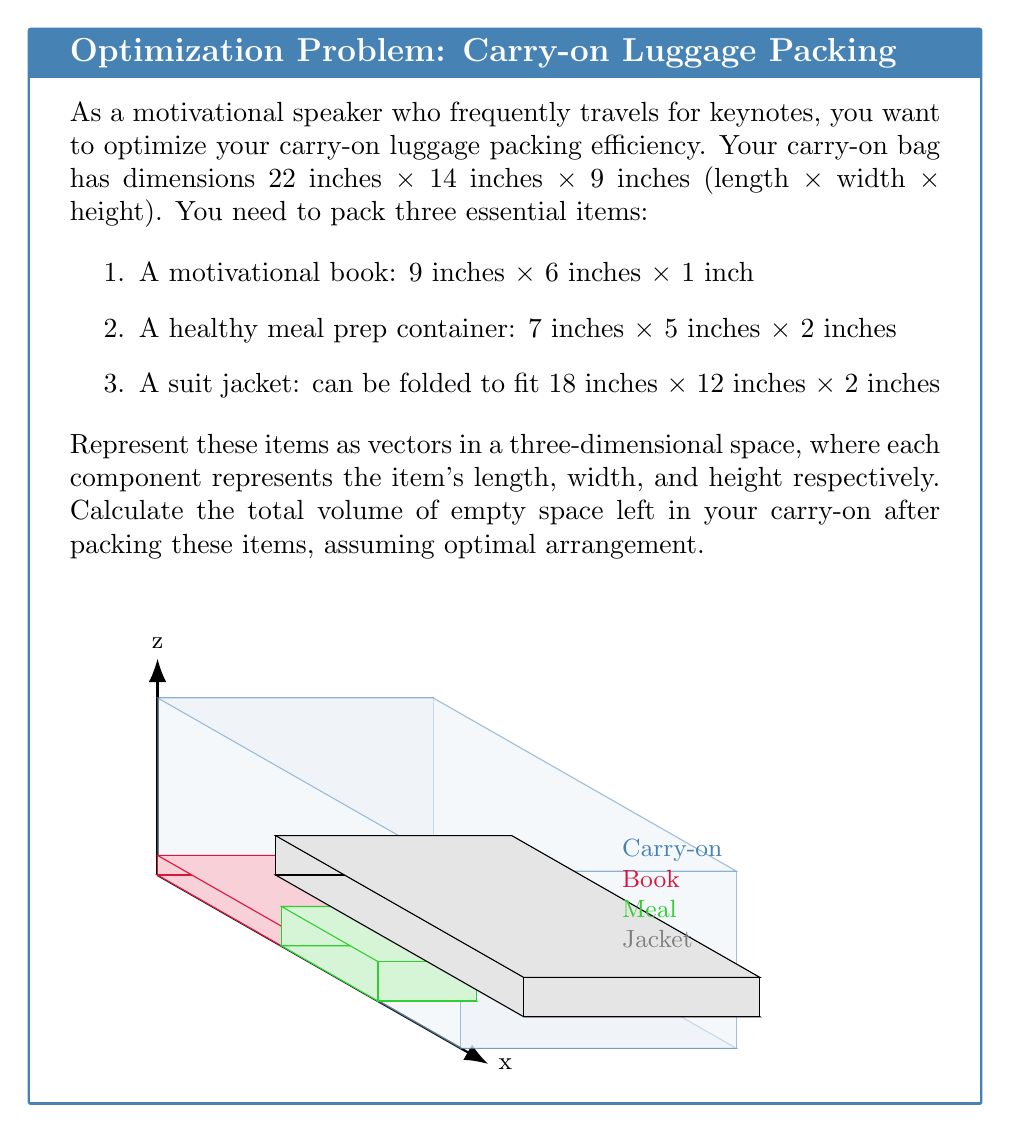What is the answer to this math problem? Let's approach this step-by-step:

1) First, let's represent each item as a vector:
   - Carry-on: $\vec{c} = \langle 22, 14, 9 \rangle$
   - Book: $\vec{b} = \langle 9, 6, 1 \rangle$
   - Meal container: $\vec{m} = \langle 7, 5, 2 \rangle$
   - Suit jacket: $\vec{s} = \langle 18, 12, 2 \rangle$

2) Calculate the volume of the carry-on:
   $V_c = 22 \times 14 \times 9 = 2772$ cubic inches

3) Calculate the volumes of each item:
   $V_b = 9 \times 6 \times 1 = 54$ cubic inches
   $V_m = 7 \times 5 \times 2 = 70$ cubic inches
   $V_s = 18 \times 12 \times 2 = 432$ cubic inches

4) Sum up the volumes of the items:
   $V_{total} = V_b + V_m + V_s = 54 + 70 + 432 = 556$ cubic inches

5) Calculate the empty space:
   $V_{empty} = V_c - V_{total} = 2772 - 556 = 2216$ cubic inches

Therefore, the total volume of empty space left in the carry-on after packing these items optimally is 2216 cubic inches.
Answer: 2216 cubic inches 